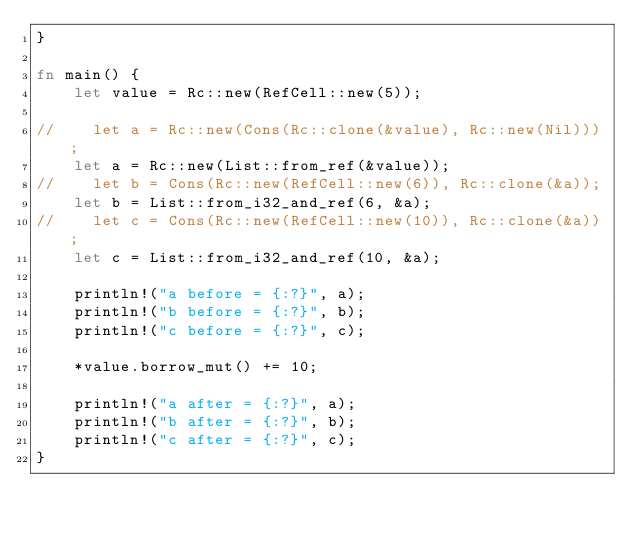Convert code to text. <code><loc_0><loc_0><loc_500><loc_500><_Rust_>}

fn main() {
    let value = Rc::new(RefCell::new(5));

//    let a = Rc::new(Cons(Rc::clone(&value), Rc::new(Nil)));
    let a = Rc::new(List::from_ref(&value));
//    let b = Cons(Rc::new(RefCell::new(6)), Rc::clone(&a));
    let b = List::from_i32_and_ref(6, &a);
//    let c = Cons(Rc::new(RefCell::new(10)), Rc::clone(&a));
    let c = List::from_i32_and_ref(10, &a);

    println!("a before = {:?}", a);
    println!("b before = {:?}", b);
    println!("c before = {:?}", c);

    *value.borrow_mut() += 10;

    println!("a after = {:?}", a);
    println!("b after = {:?}", b);
    println!("c after = {:?}", c);
}
</code> 